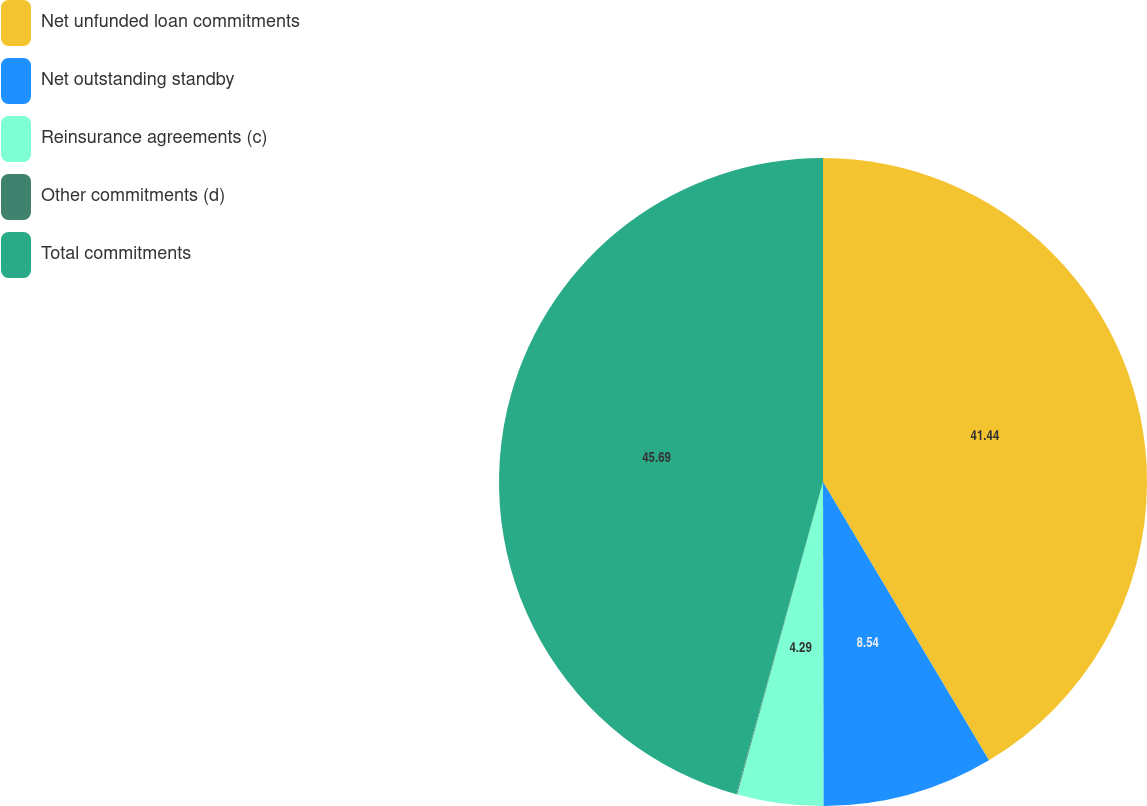Convert chart. <chart><loc_0><loc_0><loc_500><loc_500><pie_chart><fcel>Net unfunded loan commitments<fcel>Net outstanding standby<fcel>Reinsurance agreements (c)<fcel>Other commitments (d)<fcel>Total commitments<nl><fcel>41.44%<fcel>8.54%<fcel>4.29%<fcel>0.04%<fcel>45.69%<nl></chart> 